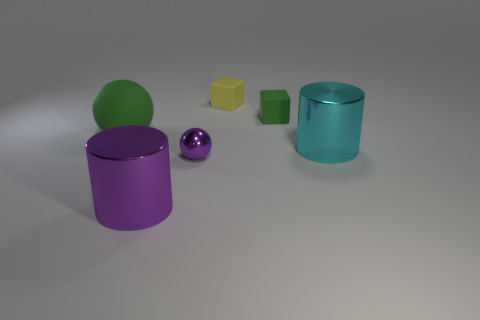Does the shiny cylinder behind the large purple object have the same color as the tiny metal object?
Keep it short and to the point. No. Does the green matte object to the right of the green ball have the same size as the sphere that is in front of the big green sphere?
Make the answer very short. Yes. What size is the purple ball that is the same material as the cyan cylinder?
Your answer should be very brief. Small. What number of big objects are both in front of the purple ball and behind the large cyan object?
Give a very brief answer. 0. What number of objects are big objects or green matte objects that are behind the large green matte ball?
Provide a succinct answer. 4. What is the shape of the object that is the same color as the large ball?
Your answer should be very brief. Cube. There is a big cylinder to the right of the purple shiny sphere; what color is it?
Give a very brief answer. Cyan. How many things are green objects that are on the right side of the small yellow matte cube or big cyan rubber spheres?
Make the answer very short. 1. There is a rubber object that is the same size as the green matte block; what is its color?
Give a very brief answer. Yellow. Is the number of small purple objects behind the big cyan metallic cylinder greater than the number of tiny green things?
Give a very brief answer. No. 